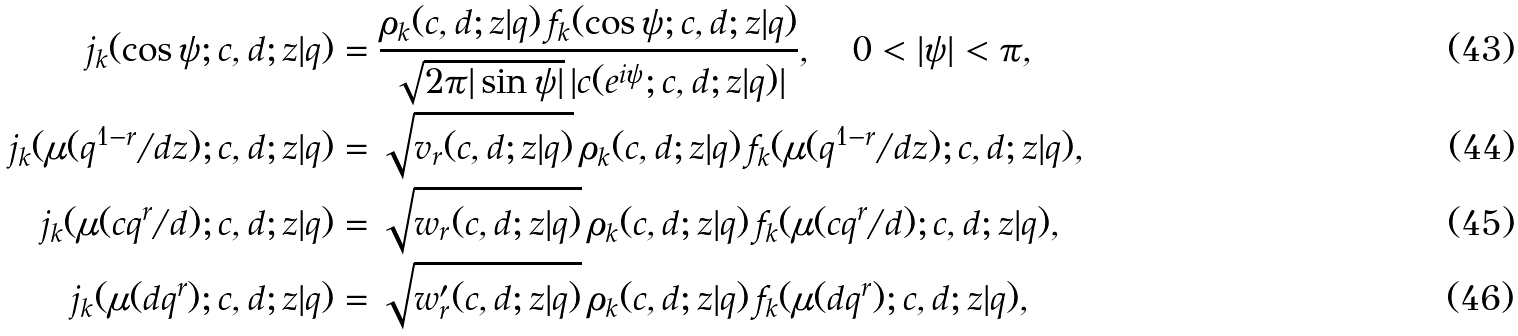<formula> <loc_0><loc_0><loc_500><loc_500>j _ { k } ( \cos \psi ; c , d ; z | q ) & = \frac { \rho _ { k } ( c , d ; z | q ) \, f _ { k } ( \cos \psi ; c , d ; z | q ) } { \sqrt { 2 \pi | \sin \psi | } \, | c ( e ^ { i \psi } ; c , d ; z | q ) | } , \quad 0 < | \psi | < \pi , \\ j _ { k } ( \mu ( q ^ { 1 - r } / d z ) ; c , d ; z | q ) & = \sqrt { v _ { r } ( c , d ; z | q ) } \, \rho _ { k } ( c , d ; z | q ) \, f _ { k } ( \mu ( q ^ { 1 - r } / d z ) ; c , d ; z | q ) , \\ j _ { k } ( \mu ( c q ^ { r } / d ) ; c , d ; z | q ) & = \sqrt { w _ { r } ( c , d ; z | q ) } \, \rho _ { k } ( c , d ; z | q ) \, f _ { k } ( \mu ( c q ^ { r } / d ) ; c , d ; z | q ) , \\ j _ { k } ( \mu ( d q ^ { r } ) ; c , d ; z | q ) & = \sqrt { w ^ { \prime } _ { r } ( c , d ; z | q ) } \, \rho _ { k } ( c , d ; z | q ) \, f _ { k } ( \mu ( d q ^ { r } ) ; c , d ; z | q ) ,</formula> 